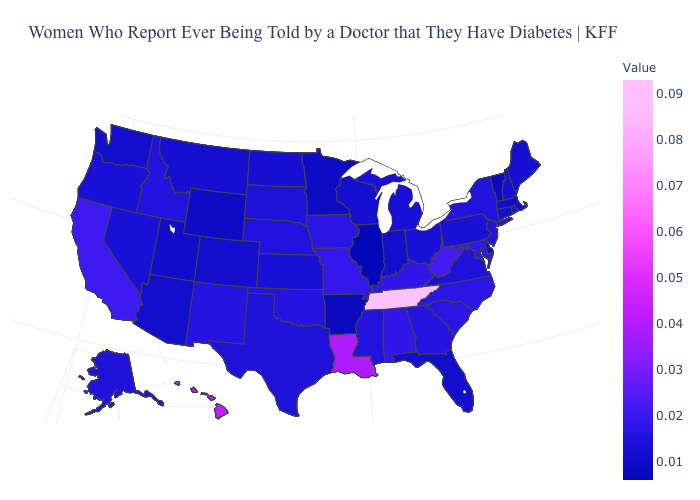Which states have the lowest value in the South?
Be succinct. Arkansas. Among the states that border Washington , which have the highest value?
Quick response, please. Idaho. Does Virginia have the highest value in the South?
Short answer required. No. Does Vermont have the lowest value in the Northeast?
Keep it brief. Yes. 